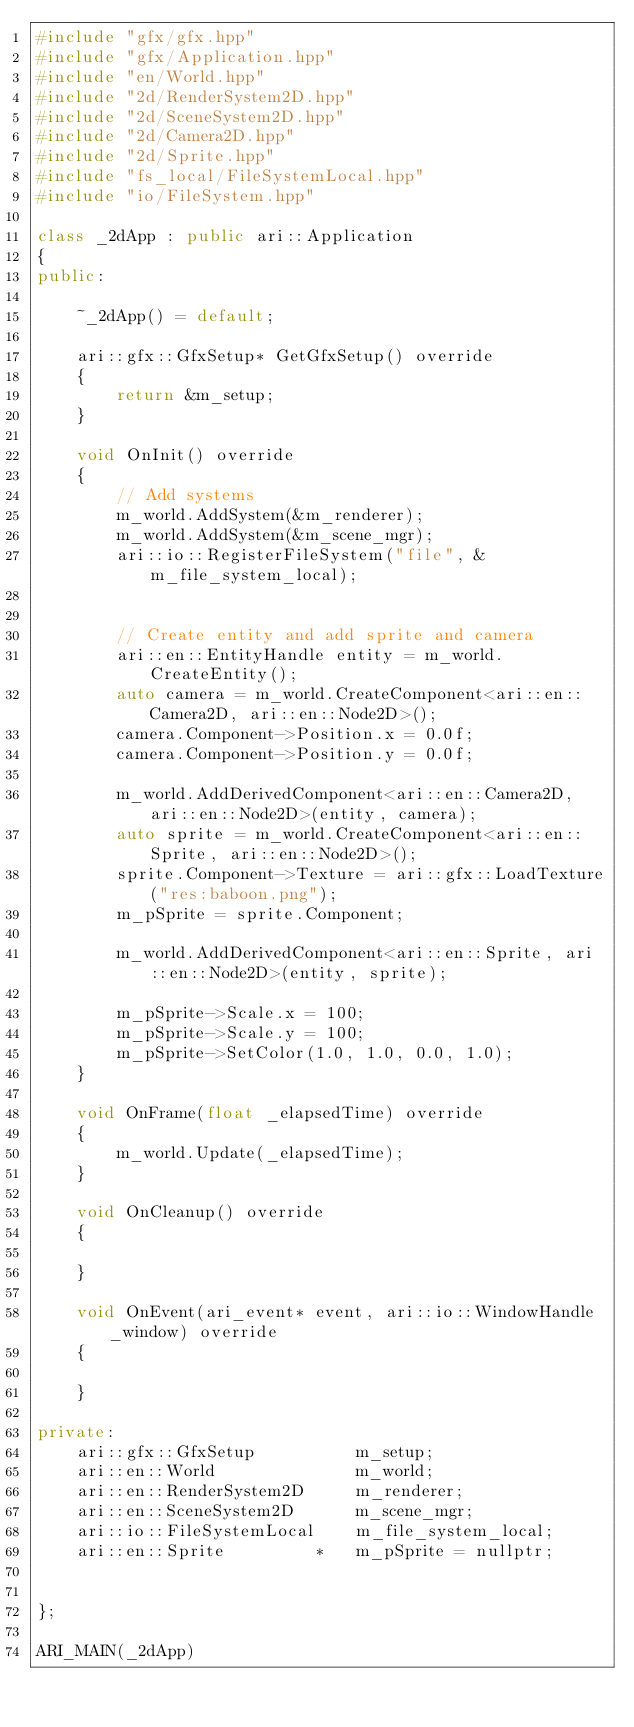<code> <loc_0><loc_0><loc_500><loc_500><_C++_>#include "gfx/gfx.hpp"
#include "gfx/Application.hpp"
#include "en/World.hpp"
#include "2d/RenderSystem2D.hpp"
#include "2d/SceneSystem2D.hpp"
#include "2d/Camera2D.hpp"
#include "2d/Sprite.hpp"
#include "fs_local/FileSystemLocal.hpp"
#include "io/FileSystem.hpp"

class _2dApp : public ari::Application
{
public:

	~_2dApp() = default;

	ari::gfx::GfxSetup* GetGfxSetup() override
	{
		return &m_setup;
	}

	void OnInit() override
	{
		// Add systems
		m_world.AddSystem(&m_renderer);
		m_world.AddSystem(&m_scene_mgr);
		ari::io::RegisterFileSystem("file", &m_file_system_local);


		// Create entity and add sprite and camera
		ari::en::EntityHandle entity = m_world.CreateEntity();
		auto camera = m_world.CreateComponent<ari::en::Camera2D, ari::en::Node2D>();
		camera.Component->Position.x = 0.0f;
		camera.Component->Position.y = 0.0f;

		m_world.AddDerivedComponent<ari::en::Camera2D, ari::en::Node2D>(entity, camera);
		auto sprite = m_world.CreateComponent<ari::en::Sprite, ari::en::Node2D>();
		sprite.Component->Texture = ari::gfx::LoadTexture("res:baboon.png");
		m_pSprite = sprite.Component;

		m_world.AddDerivedComponent<ari::en::Sprite, ari::en::Node2D>(entity, sprite);

		m_pSprite->Scale.x = 100;
		m_pSprite->Scale.y = 100;
		m_pSprite->SetColor(1.0, 1.0, 0.0, 1.0);
	}

	void OnFrame(float _elapsedTime) override
	{
		m_world.Update(_elapsedTime);
	}

	void OnCleanup() override
	{

	}

	void OnEvent(ari_event* event, ari::io::WindowHandle _window) override
	{

	}

private:
	ari::gfx::GfxSetup			m_setup;
	ari::en::World				m_world;
	ari::en::RenderSystem2D		m_renderer;
	ari::en::SceneSystem2D		m_scene_mgr;
	ari::io::FileSystemLocal	m_file_system_local;
	ari::en::Sprite			*	m_pSprite = nullptr;


};

ARI_MAIN(_2dApp)

</code> 